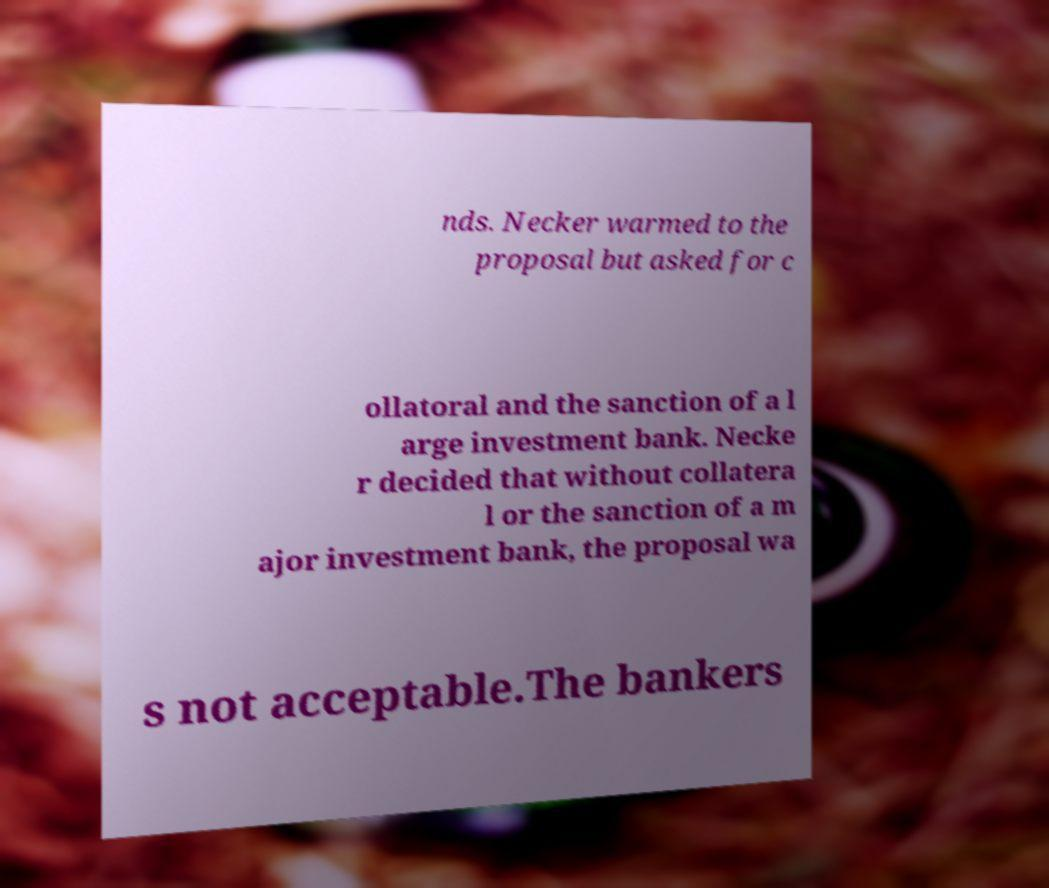What messages or text are displayed in this image? I need them in a readable, typed format. nds. Necker warmed to the proposal but asked for c ollatoral and the sanction of a l arge investment bank. Necke r decided that without collatera l or the sanction of a m ajor investment bank, the proposal wa s not acceptable.The bankers 